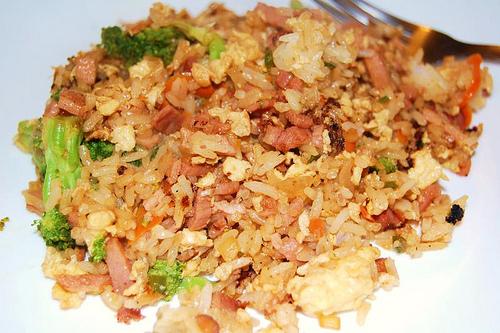Is someone currently eating this food?
Keep it brief. No. Are there carrots in this dish?
Concise answer only. No. What is the green vegetable?
Keep it brief. Broccoli. What utensil can be seen?
Quick response, please. Fork. 